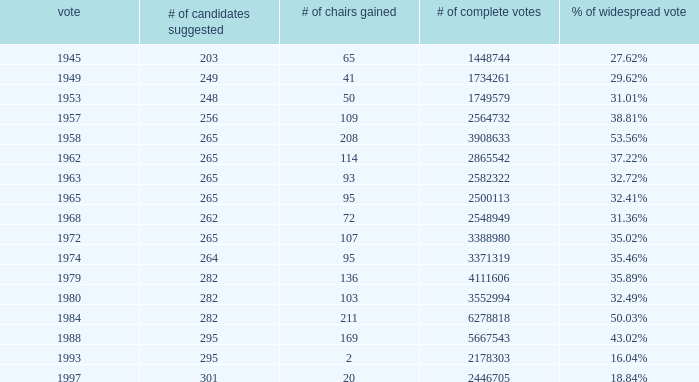What is the # of seats one for the election in 1974? 95.0. 